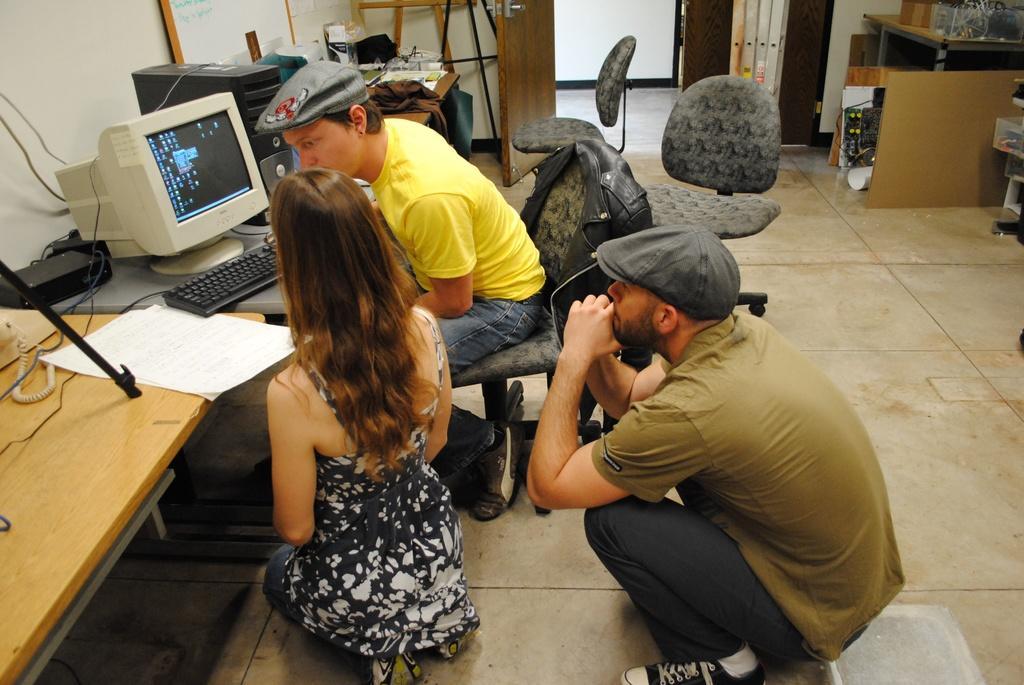Describe this image in one or two sentences. In the image we can see there are people who are sitting on chair and on the floor. 